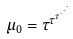<formula> <loc_0><loc_0><loc_500><loc_500>\mu _ { 0 } = \tau ^ { \tau ^ { \tau ^ { \cdot ^ { \cdot ^ { \cdot } } } } }</formula> 